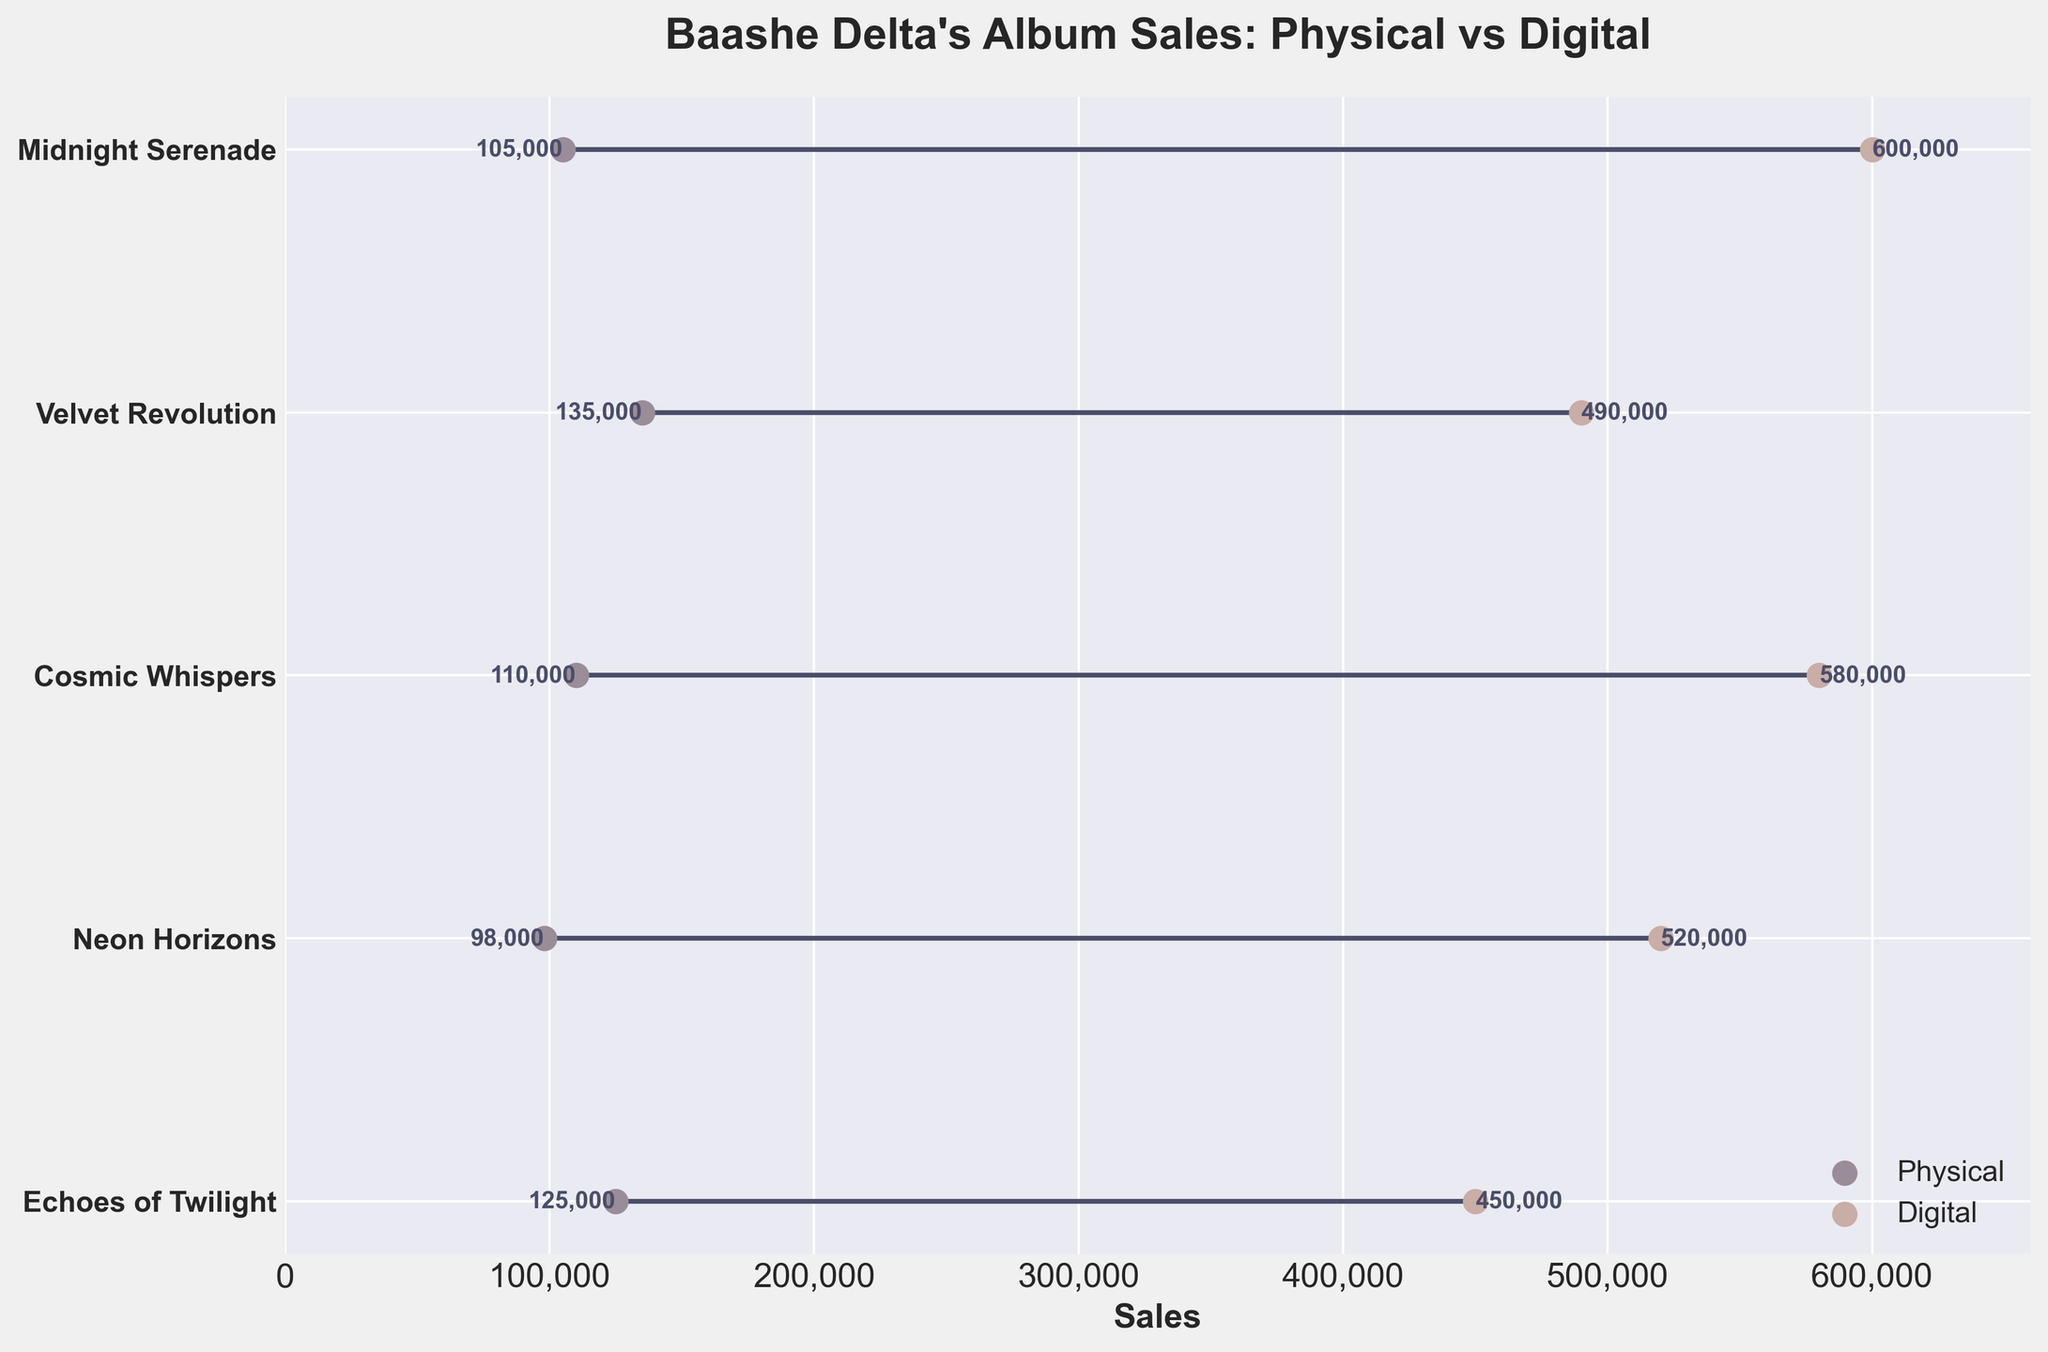What is the title of the plot? The title is given at the top of the plot, usually in a larger and bold font. It's direct textual information.
Answer: Baashe Delta's Album Sales: Physical vs Digital What is the range of the x-axis? The x-axis range can be determined by looking at the start and end labels of the x-axis.
Answer: 0 to 660,000 Which album has the highest digital sales? To find this, look at the digital sales points and identify the highest value.
Answer: Midnight Serenade What is the difference in sales between physical and digital formats for "Neon Horizons"? Identify the sales for both formats for "Neon Horizons" and subtract the physical from the digital.
Answer: 422,000 How many albums' physical sales exceeded 100,000 units? Count the number of albums with physical sales points to the right of the 100,000 units marker.
Answer: 3 Which album has the smallest gap between physical and digital sales? Calculate the difference between physical and digital sales for each album and identify the smallest gap.
Answer: Velvet Revolution What are the digital sales for "Cosmic Whispers"? Look at the digital sales point associated with "Cosmic Whispers."
Answer: 580,000 How much higher are the digital sales of "Echoes of Twilight" compared to its physical sales? Subtract the physical sales value from the digital sales value for "Echoes of Twilight."
Answer: 325,000 Which album has larger physical sales, "Cosmic Whispers" or "Midnight Serenade"? Compare the physical sales points of the two albums directly.
Answer: Cosmic Whispers What is the total sum of digital sales for all five albums? Sum the digital sales values for all albums.
Answer: 2,640,000 